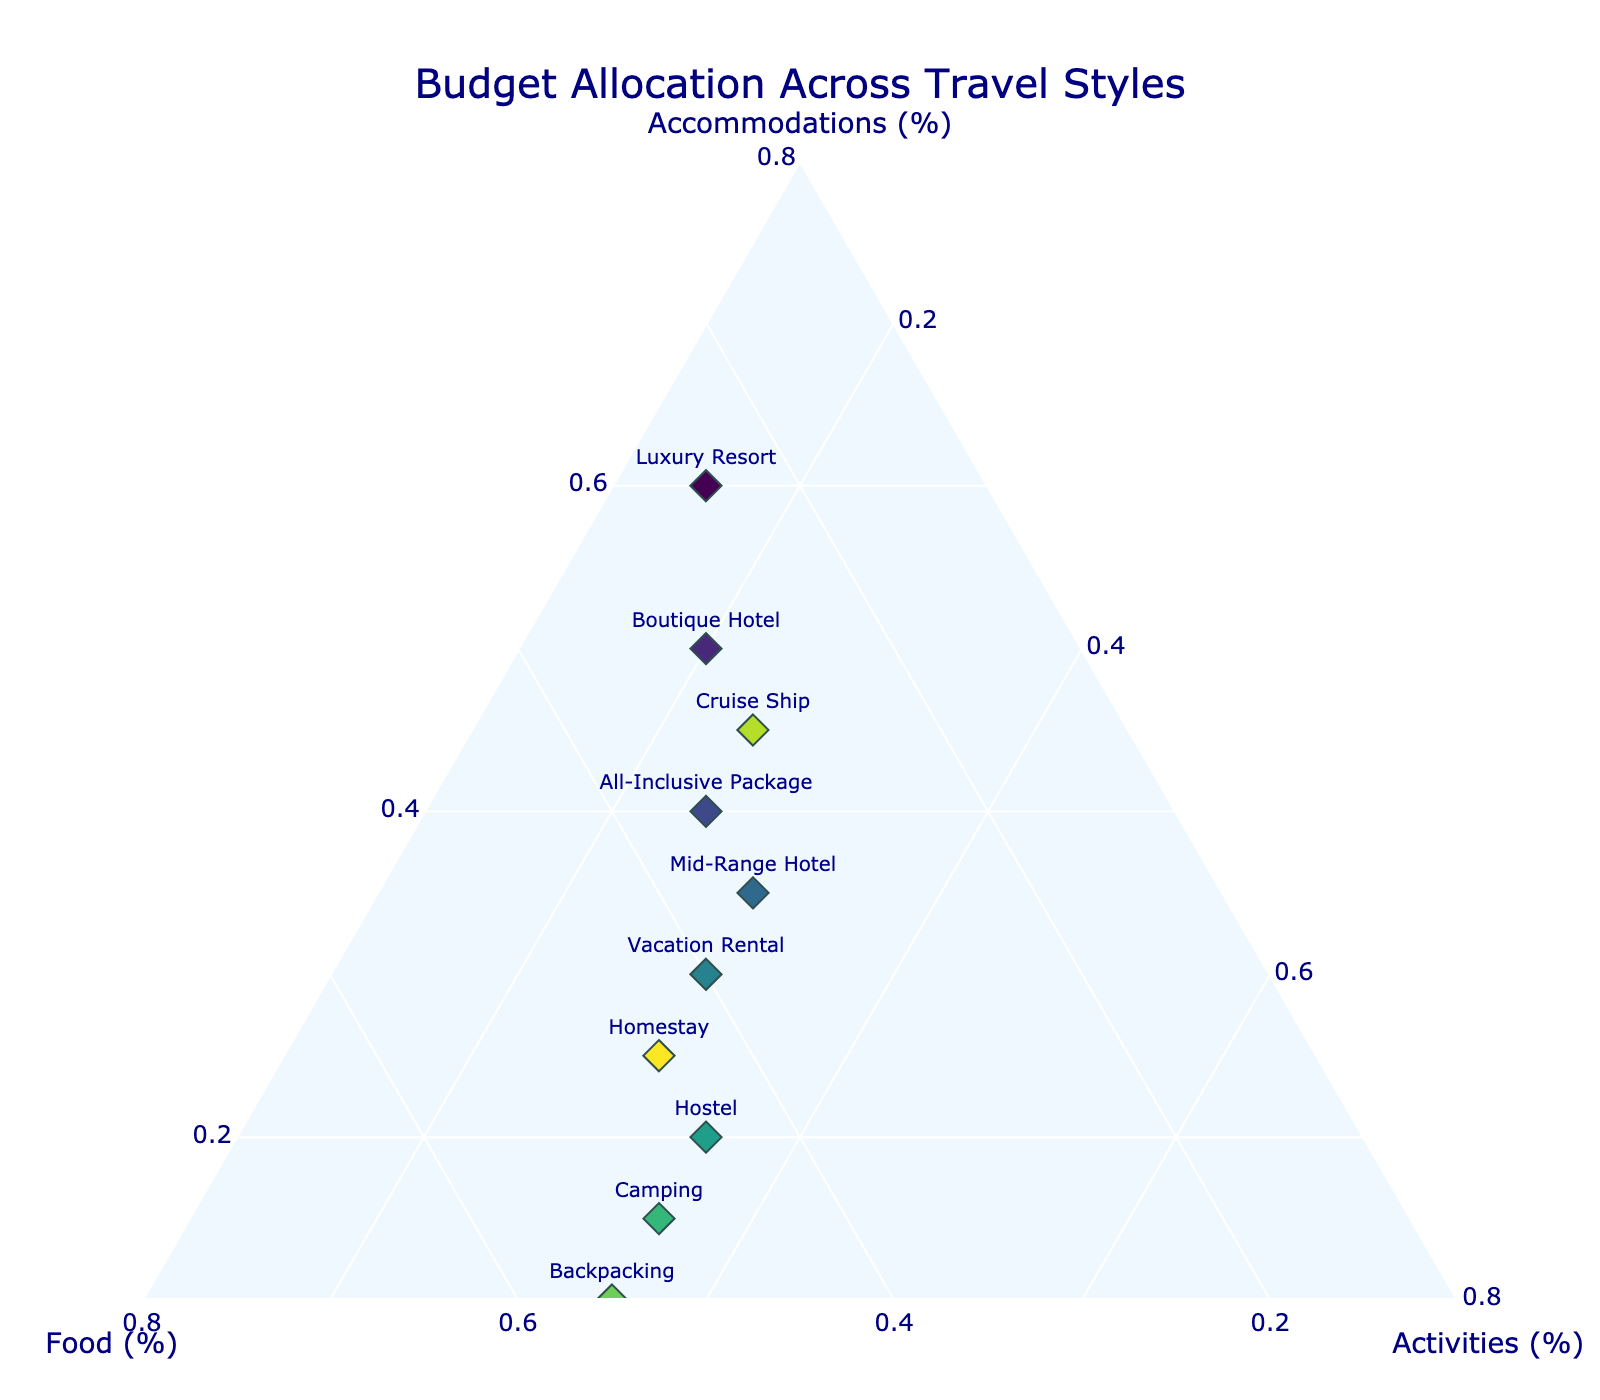What is the title of the figure? The title is prominently displayed at the top of the figure. It provides a summary of what the plot represents.
Answer: Budget Allocation Across Travel Styles How many travel styles are represented in the figure? Count the number of distinct data points, each labeled with a different travel style at the end of the markers.
Answer: 10 Which travel style allocates the highest percentage to accommodations? Look for the data point closest to the 'Accommodations' axis at the extreme left. The text label will show the travel style.
Answer: Luxury Resort Do any travel styles allocate an equal percentage to food and activities? Compare the percentage values for 'Food' and 'Activities' across all travel styles to find any that match.
Answer: No What is the average allocation to food across all travel styles? Sum up the 'Food' percentages for all travel styles and divide by the total number of travel styles. 
Calculation: (25 + 30 + 35 + 35 + 40 + 45 + 50 + 55 + 30 + 45)/10.
Answer: 39% Do any travel styles allocate more than 45% to food? Identify data points where the 'Food' percentage exceeds 45%. The text label will show the travel style names.
Answer: Hostel, Camping, and Backpacking Which travel styles have the lowest allocation to activities? Look for the data points closest to the 'Activities' axis, indicating a low percentage. The text label will show the travel style names.
Answer: Luxury Resort Compare the budget allocation for food between 'Mid-Range Hotel' and 'Homestay'. Which one allocates more to food? Check the 'Food' percentage values for 'Mid-Range Hotel' and 'Homestay' from the figure, and compare them.
Answer: Homestay (45% vs 35%) If you sum up the percentages of accommodations and activities for 'Cruise Ship', what is the result? Add the percentage values for 'Accommodations' and 'Activities' for 'Cruise Ship'. 
Calculation: 45% (Accommodations) + 25% (Activities) = 70%.
Answer: 70% Which travel style has an equal allocation to accommodations and activities? Compare the percentages of 'Accommodations' and 'Activities' for each travel style to find any matching pairs.
Answer: None 